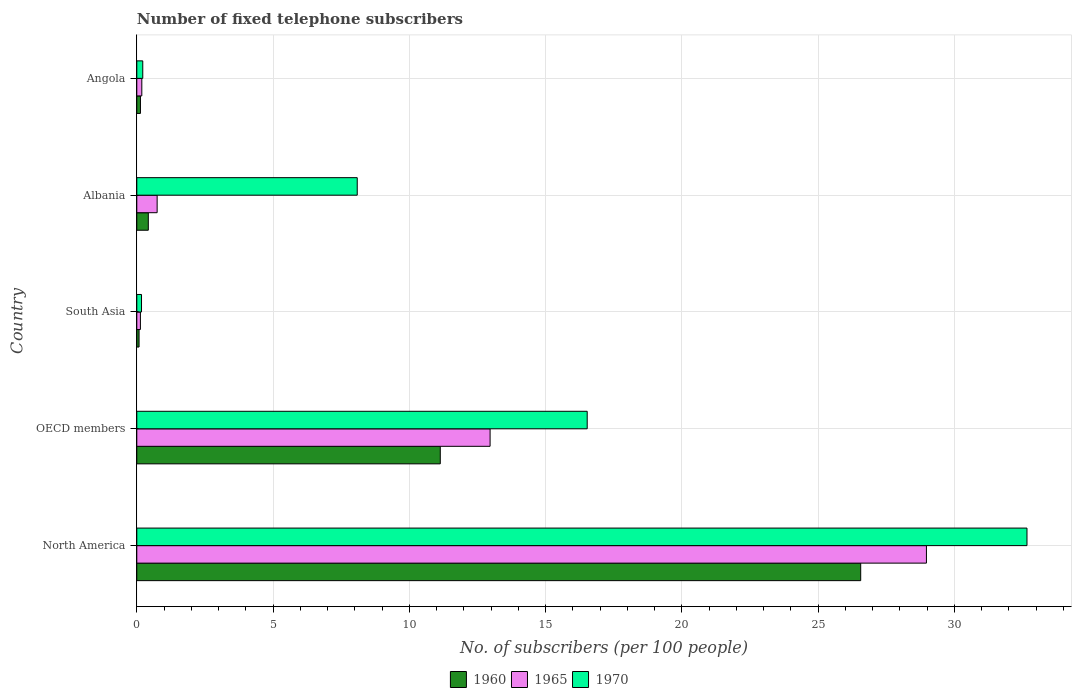How many different coloured bars are there?
Make the answer very short. 3. How many groups of bars are there?
Offer a terse response. 5. Are the number of bars on each tick of the Y-axis equal?
Your answer should be very brief. Yes. How many bars are there on the 4th tick from the top?
Offer a very short reply. 3. What is the label of the 5th group of bars from the top?
Your response must be concise. North America. What is the number of fixed telephone subscribers in 1965 in South Asia?
Ensure brevity in your answer.  0.13. Across all countries, what is the maximum number of fixed telephone subscribers in 1965?
Offer a very short reply. 28.97. Across all countries, what is the minimum number of fixed telephone subscribers in 1960?
Offer a terse response. 0.08. In which country was the number of fixed telephone subscribers in 1965 minimum?
Your response must be concise. South Asia. What is the total number of fixed telephone subscribers in 1965 in the graph?
Ensure brevity in your answer.  43. What is the difference between the number of fixed telephone subscribers in 1965 in Albania and that in North America?
Your answer should be very brief. -28.23. What is the difference between the number of fixed telephone subscribers in 1965 in South Asia and the number of fixed telephone subscribers in 1970 in OECD members?
Your answer should be compact. -16.39. What is the average number of fixed telephone subscribers in 1970 per country?
Your response must be concise. 11.53. What is the difference between the number of fixed telephone subscribers in 1965 and number of fixed telephone subscribers in 1970 in Angola?
Provide a short and direct response. -0.04. What is the ratio of the number of fixed telephone subscribers in 1965 in Angola to that in South Asia?
Your answer should be compact. 1.39. Is the number of fixed telephone subscribers in 1960 in North America less than that in South Asia?
Provide a succinct answer. No. Is the difference between the number of fixed telephone subscribers in 1965 in Angola and North America greater than the difference between the number of fixed telephone subscribers in 1970 in Angola and North America?
Offer a terse response. Yes. What is the difference between the highest and the second highest number of fixed telephone subscribers in 1965?
Give a very brief answer. 16.01. What is the difference between the highest and the lowest number of fixed telephone subscribers in 1960?
Keep it short and to the point. 26.48. Is the sum of the number of fixed telephone subscribers in 1970 in Angola and North America greater than the maximum number of fixed telephone subscribers in 1960 across all countries?
Give a very brief answer. Yes. What does the 3rd bar from the top in OECD members represents?
Keep it short and to the point. 1960. What does the 2nd bar from the bottom in North America represents?
Your response must be concise. 1965. Is it the case that in every country, the sum of the number of fixed telephone subscribers in 1965 and number of fixed telephone subscribers in 1960 is greater than the number of fixed telephone subscribers in 1970?
Offer a terse response. No. How many bars are there?
Ensure brevity in your answer.  15. Are the values on the major ticks of X-axis written in scientific E-notation?
Keep it short and to the point. No. Does the graph contain any zero values?
Keep it short and to the point. No. Where does the legend appear in the graph?
Provide a succinct answer. Bottom center. How are the legend labels stacked?
Provide a short and direct response. Horizontal. What is the title of the graph?
Keep it short and to the point. Number of fixed telephone subscribers. What is the label or title of the X-axis?
Offer a terse response. No. of subscribers (per 100 people). What is the label or title of the Y-axis?
Your answer should be very brief. Country. What is the No. of subscribers (per 100 people) in 1960 in North America?
Your answer should be compact. 26.56. What is the No. of subscribers (per 100 people) in 1965 in North America?
Give a very brief answer. 28.97. What is the No. of subscribers (per 100 people) of 1970 in North America?
Provide a succinct answer. 32.66. What is the No. of subscribers (per 100 people) in 1960 in OECD members?
Give a very brief answer. 11.13. What is the No. of subscribers (per 100 people) of 1965 in OECD members?
Make the answer very short. 12.96. What is the No. of subscribers (per 100 people) in 1970 in OECD members?
Provide a succinct answer. 16.53. What is the No. of subscribers (per 100 people) of 1960 in South Asia?
Make the answer very short. 0.08. What is the No. of subscribers (per 100 people) of 1965 in South Asia?
Make the answer very short. 0.13. What is the No. of subscribers (per 100 people) of 1970 in South Asia?
Make the answer very short. 0.17. What is the No. of subscribers (per 100 people) of 1960 in Albania?
Offer a terse response. 0.42. What is the No. of subscribers (per 100 people) in 1965 in Albania?
Provide a succinct answer. 0.75. What is the No. of subscribers (per 100 people) in 1970 in Albania?
Your answer should be compact. 8.09. What is the No. of subscribers (per 100 people) in 1960 in Angola?
Your response must be concise. 0.13. What is the No. of subscribers (per 100 people) in 1965 in Angola?
Offer a terse response. 0.18. What is the No. of subscribers (per 100 people) in 1970 in Angola?
Keep it short and to the point. 0.22. Across all countries, what is the maximum No. of subscribers (per 100 people) of 1960?
Ensure brevity in your answer.  26.56. Across all countries, what is the maximum No. of subscribers (per 100 people) in 1965?
Keep it short and to the point. 28.97. Across all countries, what is the maximum No. of subscribers (per 100 people) of 1970?
Provide a short and direct response. 32.66. Across all countries, what is the minimum No. of subscribers (per 100 people) in 1960?
Provide a succinct answer. 0.08. Across all countries, what is the minimum No. of subscribers (per 100 people) in 1965?
Give a very brief answer. 0.13. Across all countries, what is the minimum No. of subscribers (per 100 people) of 1970?
Give a very brief answer. 0.17. What is the total No. of subscribers (per 100 people) in 1960 in the graph?
Provide a short and direct response. 38.34. What is the total No. of subscribers (per 100 people) of 1965 in the graph?
Your answer should be compact. 43. What is the total No. of subscribers (per 100 people) of 1970 in the graph?
Your answer should be very brief. 57.67. What is the difference between the No. of subscribers (per 100 people) in 1960 in North America and that in OECD members?
Your answer should be compact. 15.43. What is the difference between the No. of subscribers (per 100 people) in 1965 in North America and that in OECD members?
Your response must be concise. 16.01. What is the difference between the No. of subscribers (per 100 people) of 1970 in North America and that in OECD members?
Offer a very short reply. 16.14. What is the difference between the No. of subscribers (per 100 people) of 1960 in North America and that in South Asia?
Provide a short and direct response. 26.48. What is the difference between the No. of subscribers (per 100 people) of 1965 in North America and that in South Asia?
Your response must be concise. 28.84. What is the difference between the No. of subscribers (per 100 people) in 1970 in North America and that in South Asia?
Offer a very short reply. 32.49. What is the difference between the No. of subscribers (per 100 people) in 1960 in North America and that in Albania?
Provide a succinct answer. 26.14. What is the difference between the No. of subscribers (per 100 people) of 1965 in North America and that in Albania?
Offer a terse response. 28.23. What is the difference between the No. of subscribers (per 100 people) of 1970 in North America and that in Albania?
Keep it short and to the point. 24.57. What is the difference between the No. of subscribers (per 100 people) in 1960 in North America and that in Angola?
Offer a very short reply. 26.43. What is the difference between the No. of subscribers (per 100 people) in 1965 in North America and that in Angola?
Your answer should be compact. 28.79. What is the difference between the No. of subscribers (per 100 people) in 1970 in North America and that in Angola?
Give a very brief answer. 32.44. What is the difference between the No. of subscribers (per 100 people) of 1960 in OECD members and that in South Asia?
Offer a terse response. 11.05. What is the difference between the No. of subscribers (per 100 people) in 1965 in OECD members and that in South Asia?
Offer a very short reply. 12.83. What is the difference between the No. of subscribers (per 100 people) of 1970 in OECD members and that in South Asia?
Provide a short and direct response. 16.35. What is the difference between the No. of subscribers (per 100 people) in 1960 in OECD members and that in Albania?
Ensure brevity in your answer.  10.71. What is the difference between the No. of subscribers (per 100 people) in 1965 in OECD members and that in Albania?
Ensure brevity in your answer.  12.22. What is the difference between the No. of subscribers (per 100 people) in 1970 in OECD members and that in Albania?
Your answer should be compact. 8.44. What is the difference between the No. of subscribers (per 100 people) of 1960 in OECD members and that in Angola?
Make the answer very short. 11. What is the difference between the No. of subscribers (per 100 people) of 1965 in OECD members and that in Angola?
Offer a terse response. 12.78. What is the difference between the No. of subscribers (per 100 people) in 1970 in OECD members and that in Angola?
Your response must be concise. 16.31. What is the difference between the No. of subscribers (per 100 people) of 1960 in South Asia and that in Albania?
Offer a terse response. -0.34. What is the difference between the No. of subscribers (per 100 people) of 1965 in South Asia and that in Albania?
Provide a succinct answer. -0.61. What is the difference between the No. of subscribers (per 100 people) of 1970 in South Asia and that in Albania?
Your response must be concise. -7.91. What is the difference between the No. of subscribers (per 100 people) in 1960 in South Asia and that in Angola?
Your response must be concise. -0.05. What is the difference between the No. of subscribers (per 100 people) in 1965 in South Asia and that in Angola?
Your answer should be very brief. -0.05. What is the difference between the No. of subscribers (per 100 people) in 1970 in South Asia and that in Angola?
Make the answer very short. -0.05. What is the difference between the No. of subscribers (per 100 people) in 1960 in Albania and that in Angola?
Offer a very short reply. 0.29. What is the difference between the No. of subscribers (per 100 people) of 1965 in Albania and that in Angola?
Provide a succinct answer. 0.56. What is the difference between the No. of subscribers (per 100 people) of 1970 in Albania and that in Angola?
Keep it short and to the point. 7.87. What is the difference between the No. of subscribers (per 100 people) of 1960 in North America and the No. of subscribers (per 100 people) of 1965 in OECD members?
Provide a succinct answer. 13.6. What is the difference between the No. of subscribers (per 100 people) in 1960 in North America and the No. of subscribers (per 100 people) in 1970 in OECD members?
Provide a succinct answer. 10.03. What is the difference between the No. of subscribers (per 100 people) in 1965 in North America and the No. of subscribers (per 100 people) in 1970 in OECD members?
Your response must be concise. 12.45. What is the difference between the No. of subscribers (per 100 people) in 1960 in North America and the No. of subscribers (per 100 people) in 1965 in South Asia?
Your response must be concise. 26.43. What is the difference between the No. of subscribers (per 100 people) in 1960 in North America and the No. of subscribers (per 100 people) in 1970 in South Asia?
Keep it short and to the point. 26.39. What is the difference between the No. of subscribers (per 100 people) of 1965 in North America and the No. of subscribers (per 100 people) of 1970 in South Asia?
Offer a terse response. 28.8. What is the difference between the No. of subscribers (per 100 people) in 1960 in North America and the No. of subscribers (per 100 people) in 1965 in Albania?
Your response must be concise. 25.81. What is the difference between the No. of subscribers (per 100 people) of 1960 in North America and the No. of subscribers (per 100 people) of 1970 in Albania?
Offer a very short reply. 18.47. What is the difference between the No. of subscribers (per 100 people) of 1965 in North America and the No. of subscribers (per 100 people) of 1970 in Albania?
Your answer should be compact. 20.88. What is the difference between the No. of subscribers (per 100 people) of 1960 in North America and the No. of subscribers (per 100 people) of 1965 in Angola?
Provide a succinct answer. 26.38. What is the difference between the No. of subscribers (per 100 people) of 1960 in North America and the No. of subscribers (per 100 people) of 1970 in Angola?
Offer a terse response. 26.34. What is the difference between the No. of subscribers (per 100 people) in 1965 in North America and the No. of subscribers (per 100 people) in 1970 in Angola?
Give a very brief answer. 28.75. What is the difference between the No. of subscribers (per 100 people) in 1960 in OECD members and the No. of subscribers (per 100 people) in 1965 in South Asia?
Provide a succinct answer. 11. What is the difference between the No. of subscribers (per 100 people) of 1960 in OECD members and the No. of subscribers (per 100 people) of 1970 in South Asia?
Give a very brief answer. 10.96. What is the difference between the No. of subscribers (per 100 people) of 1965 in OECD members and the No. of subscribers (per 100 people) of 1970 in South Asia?
Keep it short and to the point. 12.79. What is the difference between the No. of subscribers (per 100 people) in 1960 in OECD members and the No. of subscribers (per 100 people) in 1965 in Albania?
Your answer should be very brief. 10.39. What is the difference between the No. of subscribers (per 100 people) in 1960 in OECD members and the No. of subscribers (per 100 people) in 1970 in Albania?
Make the answer very short. 3.05. What is the difference between the No. of subscribers (per 100 people) in 1965 in OECD members and the No. of subscribers (per 100 people) in 1970 in Albania?
Ensure brevity in your answer.  4.87. What is the difference between the No. of subscribers (per 100 people) in 1960 in OECD members and the No. of subscribers (per 100 people) in 1965 in Angola?
Your response must be concise. 10.95. What is the difference between the No. of subscribers (per 100 people) of 1960 in OECD members and the No. of subscribers (per 100 people) of 1970 in Angola?
Your response must be concise. 10.92. What is the difference between the No. of subscribers (per 100 people) in 1965 in OECD members and the No. of subscribers (per 100 people) in 1970 in Angola?
Your response must be concise. 12.74. What is the difference between the No. of subscribers (per 100 people) of 1960 in South Asia and the No. of subscribers (per 100 people) of 1965 in Albania?
Give a very brief answer. -0.66. What is the difference between the No. of subscribers (per 100 people) of 1960 in South Asia and the No. of subscribers (per 100 people) of 1970 in Albania?
Your response must be concise. -8. What is the difference between the No. of subscribers (per 100 people) in 1965 in South Asia and the No. of subscribers (per 100 people) in 1970 in Albania?
Provide a succinct answer. -7.96. What is the difference between the No. of subscribers (per 100 people) of 1960 in South Asia and the No. of subscribers (per 100 people) of 1965 in Angola?
Provide a short and direct response. -0.1. What is the difference between the No. of subscribers (per 100 people) in 1960 in South Asia and the No. of subscribers (per 100 people) in 1970 in Angola?
Keep it short and to the point. -0.14. What is the difference between the No. of subscribers (per 100 people) of 1965 in South Asia and the No. of subscribers (per 100 people) of 1970 in Angola?
Provide a short and direct response. -0.09. What is the difference between the No. of subscribers (per 100 people) of 1960 in Albania and the No. of subscribers (per 100 people) of 1965 in Angola?
Give a very brief answer. 0.24. What is the difference between the No. of subscribers (per 100 people) of 1960 in Albania and the No. of subscribers (per 100 people) of 1970 in Angola?
Provide a succinct answer. 0.2. What is the difference between the No. of subscribers (per 100 people) of 1965 in Albania and the No. of subscribers (per 100 people) of 1970 in Angola?
Your answer should be very brief. 0.53. What is the average No. of subscribers (per 100 people) in 1960 per country?
Your answer should be very brief. 7.67. What is the average No. of subscribers (per 100 people) in 1965 per country?
Your answer should be compact. 8.6. What is the average No. of subscribers (per 100 people) of 1970 per country?
Your answer should be compact. 11.53. What is the difference between the No. of subscribers (per 100 people) of 1960 and No. of subscribers (per 100 people) of 1965 in North America?
Your answer should be very brief. -2.41. What is the difference between the No. of subscribers (per 100 people) in 1960 and No. of subscribers (per 100 people) in 1970 in North America?
Your answer should be very brief. -6.1. What is the difference between the No. of subscribers (per 100 people) in 1965 and No. of subscribers (per 100 people) in 1970 in North America?
Ensure brevity in your answer.  -3.69. What is the difference between the No. of subscribers (per 100 people) of 1960 and No. of subscribers (per 100 people) of 1965 in OECD members?
Provide a short and direct response. -1.83. What is the difference between the No. of subscribers (per 100 people) of 1960 and No. of subscribers (per 100 people) of 1970 in OECD members?
Make the answer very short. -5.39. What is the difference between the No. of subscribers (per 100 people) in 1965 and No. of subscribers (per 100 people) in 1970 in OECD members?
Your response must be concise. -3.56. What is the difference between the No. of subscribers (per 100 people) in 1960 and No. of subscribers (per 100 people) in 1965 in South Asia?
Provide a succinct answer. -0.05. What is the difference between the No. of subscribers (per 100 people) in 1960 and No. of subscribers (per 100 people) in 1970 in South Asia?
Offer a very short reply. -0.09. What is the difference between the No. of subscribers (per 100 people) of 1965 and No. of subscribers (per 100 people) of 1970 in South Asia?
Give a very brief answer. -0.04. What is the difference between the No. of subscribers (per 100 people) in 1960 and No. of subscribers (per 100 people) in 1965 in Albania?
Provide a succinct answer. -0.32. What is the difference between the No. of subscribers (per 100 people) of 1960 and No. of subscribers (per 100 people) of 1970 in Albania?
Provide a succinct answer. -7.67. What is the difference between the No. of subscribers (per 100 people) of 1965 and No. of subscribers (per 100 people) of 1970 in Albania?
Make the answer very short. -7.34. What is the difference between the No. of subscribers (per 100 people) of 1960 and No. of subscribers (per 100 people) of 1965 in Angola?
Your answer should be very brief. -0.05. What is the difference between the No. of subscribers (per 100 people) of 1960 and No. of subscribers (per 100 people) of 1970 in Angola?
Give a very brief answer. -0.09. What is the difference between the No. of subscribers (per 100 people) in 1965 and No. of subscribers (per 100 people) in 1970 in Angola?
Provide a succinct answer. -0.04. What is the ratio of the No. of subscribers (per 100 people) of 1960 in North America to that in OECD members?
Keep it short and to the point. 2.39. What is the ratio of the No. of subscribers (per 100 people) of 1965 in North America to that in OECD members?
Offer a terse response. 2.24. What is the ratio of the No. of subscribers (per 100 people) in 1970 in North America to that in OECD members?
Make the answer very short. 1.98. What is the ratio of the No. of subscribers (per 100 people) of 1960 in North America to that in South Asia?
Provide a short and direct response. 317.76. What is the ratio of the No. of subscribers (per 100 people) of 1965 in North America to that in South Asia?
Keep it short and to the point. 218.57. What is the ratio of the No. of subscribers (per 100 people) in 1970 in North America to that in South Asia?
Provide a short and direct response. 188.62. What is the ratio of the No. of subscribers (per 100 people) of 1960 in North America to that in Albania?
Offer a very short reply. 62.81. What is the ratio of the No. of subscribers (per 100 people) in 1965 in North America to that in Albania?
Offer a very short reply. 38.81. What is the ratio of the No. of subscribers (per 100 people) in 1970 in North America to that in Albania?
Your response must be concise. 4.04. What is the ratio of the No. of subscribers (per 100 people) in 1960 in North America to that in Angola?
Provide a short and direct response. 197.86. What is the ratio of the No. of subscribers (per 100 people) of 1965 in North America to that in Angola?
Keep it short and to the point. 157.43. What is the ratio of the No. of subscribers (per 100 people) of 1970 in North America to that in Angola?
Your response must be concise. 148.93. What is the ratio of the No. of subscribers (per 100 people) in 1960 in OECD members to that in South Asia?
Your answer should be very brief. 133.22. What is the ratio of the No. of subscribers (per 100 people) in 1965 in OECD members to that in South Asia?
Offer a very short reply. 97.79. What is the ratio of the No. of subscribers (per 100 people) of 1970 in OECD members to that in South Asia?
Give a very brief answer. 95.44. What is the ratio of the No. of subscribers (per 100 people) of 1960 in OECD members to that in Albania?
Give a very brief answer. 26.33. What is the ratio of the No. of subscribers (per 100 people) of 1965 in OECD members to that in Albania?
Make the answer very short. 17.36. What is the ratio of the No. of subscribers (per 100 people) in 1970 in OECD members to that in Albania?
Your response must be concise. 2.04. What is the ratio of the No. of subscribers (per 100 people) of 1960 in OECD members to that in Angola?
Ensure brevity in your answer.  82.95. What is the ratio of the No. of subscribers (per 100 people) in 1965 in OECD members to that in Angola?
Give a very brief answer. 70.43. What is the ratio of the No. of subscribers (per 100 people) in 1970 in OECD members to that in Angola?
Make the answer very short. 75.36. What is the ratio of the No. of subscribers (per 100 people) in 1960 in South Asia to that in Albania?
Keep it short and to the point. 0.2. What is the ratio of the No. of subscribers (per 100 people) in 1965 in South Asia to that in Albania?
Your answer should be very brief. 0.18. What is the ratio of the No. of subscribers (per 100 people) in 1970 in South Asia to that in Albania?
Make the answer very short. 0.02. What is the ratio of the No. of subscribers (per 100 people) of 1960 in South Asia to that in Angola?
Your answer should be compact. 0.62. What is the ratio of the No. of subscribers (per 100 people) in 1965 in South Asia to that in Angola?
Make the answer very short. 0.72. What is the ratio of the No. of subscribers (per 100 people) in 1970 in South Asia to that in Angola?
Ensure brevity in your answer.  0.79. What is the ratio of the No. of subscribers (per 100 people) of 1960 in Albania to that in Angola?
Make the answer very short. 3.15. What is the ratio of the No. of subscribers (per 100 people) in 1965 in Albania to that in Angola?
Provide a short and direct response. 4.06. What is the ratio of the No. of subscribers (per 100 people) in 1970 in Albania to that in Angola?
Keep it short and to the point. 36.88. What is the difference between the highest and the second highest No. of subscribers (per 100 people) of 1960?
Offer a terse response. 15.43. What is the difference between the highest and the second highest No. of subscribers (per 100 people) of 1965?
Give a very brief answer. 16.01. What is the difference between the highest and the second highest No. of subscribers (per 100 people) in 1970?
Your answer should be compact. 16.14. What is the difference between the highest and the lowest No. of subscribers (per 100 people) in 1960?
Offer a very short reply. 26.48. What is the difference between the highest and the lowest No. of subscribers (per 100 people) in 1965?
Make the answer very short. 28.84. What is the difference between the highest and the lowest No. of subscribers (per 100 people) in 1970?
Your response must be concise. 32.49. 